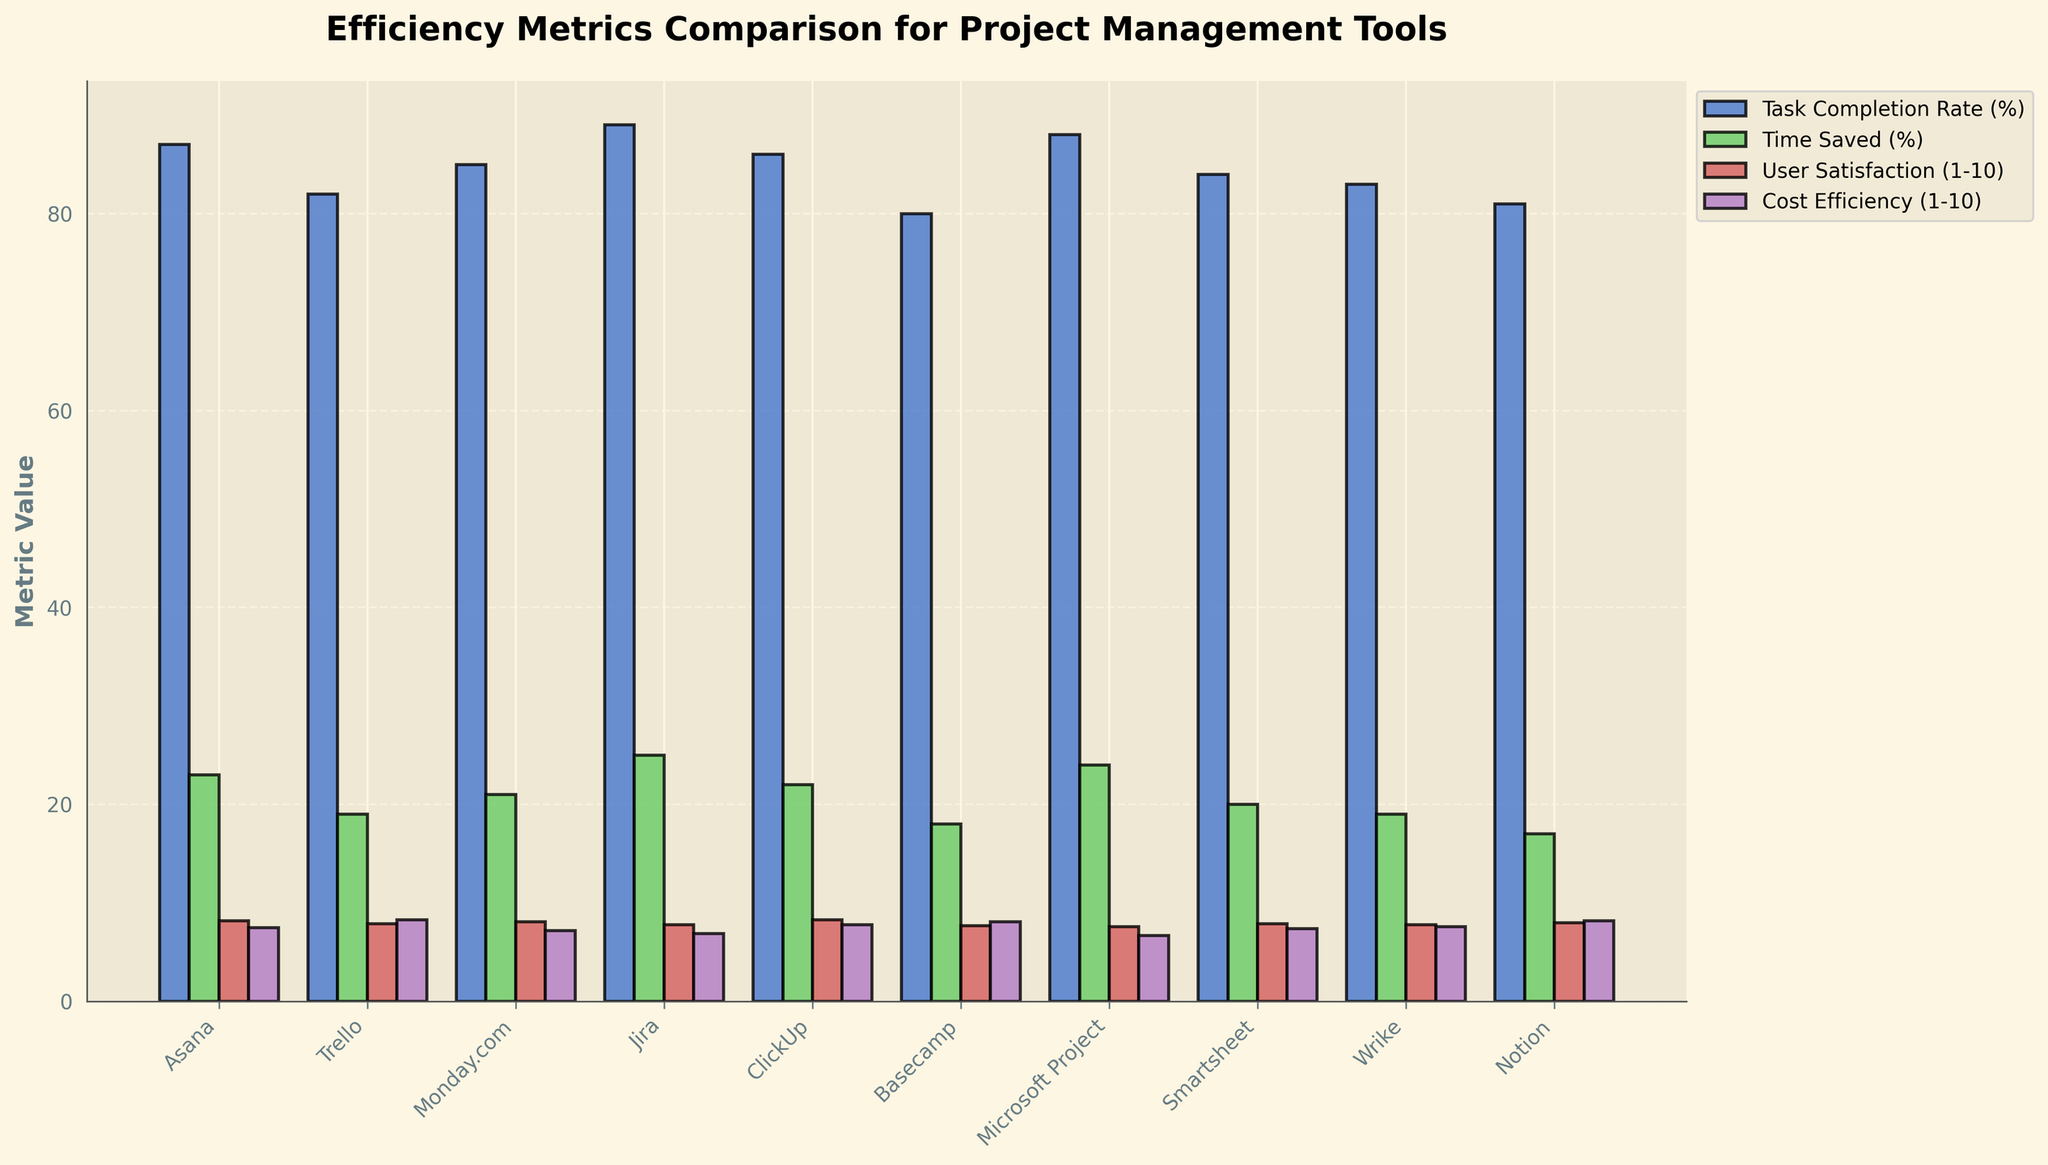Which tool has the highest Task Completion Rate? Looking at the height of the bars representing Task Completion Rate (%), Jira has the highest bar.
Answer: Jira Which tool has the lowest User Satisfaction score? Observing the bars representing User Satisfaction (1-10), Microsoft Project has the lowest bar.
Answer: Microsoft Project What is the difference in the Task Completion Rate between Basecamp and Jira? Basecamp's Task Completion Rate is 80%, and Jira's is 89%. The difference is 89% - 80% = 9%.
Answer: 9% Which tool has the greatest percentage of Time Saved? By comparing the heights of the bars for Time Saved (%), Jira has the highest bar.
Answer: Jira How does Trello's Cost Efficiency compare to ClickUp's? Trello's Cost Efficiency is 8.3, while ClickUp's is 7.8. Comparatively, Trello has a higher Cost Efficiency score.
Answer: Trello What is the average User Satisfaction score for Asana and Monday.com? Asana's User Satisfaction is 8.2 and Monday.com's is 8.1. The average is (8.2 + 8.1) / 2 = 8.15.
Answer: 8.15 Which tool has the most balanced scores across all four metrics? By visually examining the bars for all four metrics (Task Completion Rate, Time Saved, User Satisfaction, Cost Efficiency), ClickUp shows relatively balanced heights for all metrics.
Answer: ClickUp How much Time Saved does Wrike have compared to Smartsheet? Wrike's Time Saved is 19%, and Smartsheet's is 20%. The difference is 20% - 19% = 1%.
Answer: 1% What is the average Task Completion Rate across all tools? Sum the Task Completion Rates (87 + 82 + 85 + 89 + 86 + 80 + 88 + 84 + 83 + 81) = 845. The average is 845 / 10 = 84.5.
Answer: 84.5 What is the overall User Satisfaction sum of Notion and Basecamp? Notion's User Satisfaction is 8.0 and Basecamp's is 7.7. The sum is 8.0 + 7.7 = 15.7.
Answer: 15.7 